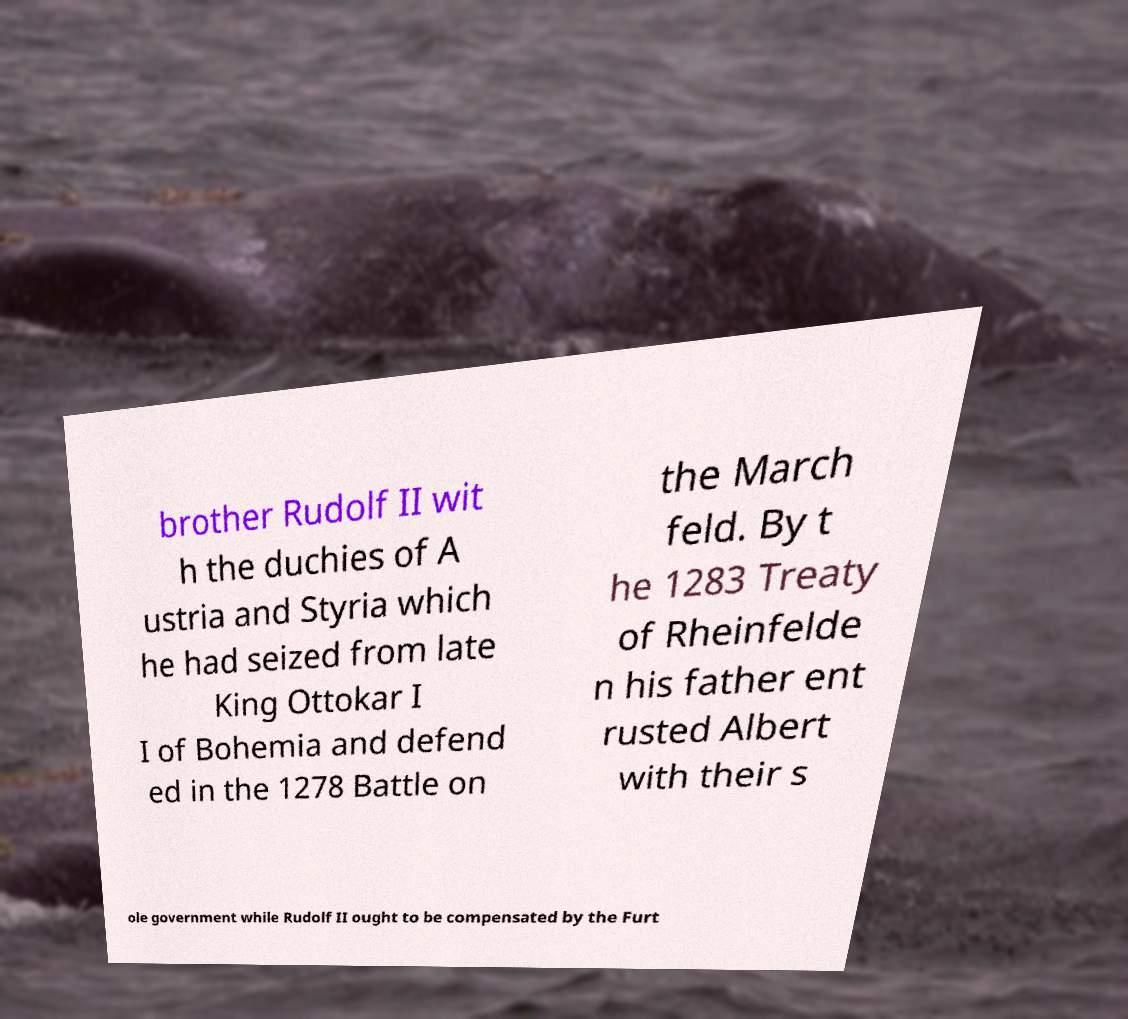There's text embedded in this image that I need extracted. Can you transcribe it verbatim? brother Rudolf II wit h the duchies of A ustria and Styria which he had seized from late King Ottokar I I of Bohemia and defend ed in the 1278 Battle on the March feld. By t he 1283 Treaty of Rheinfelde n his father ent rusted Albert with their s ole government while Rudolf II ought to be compensated by the Furt 